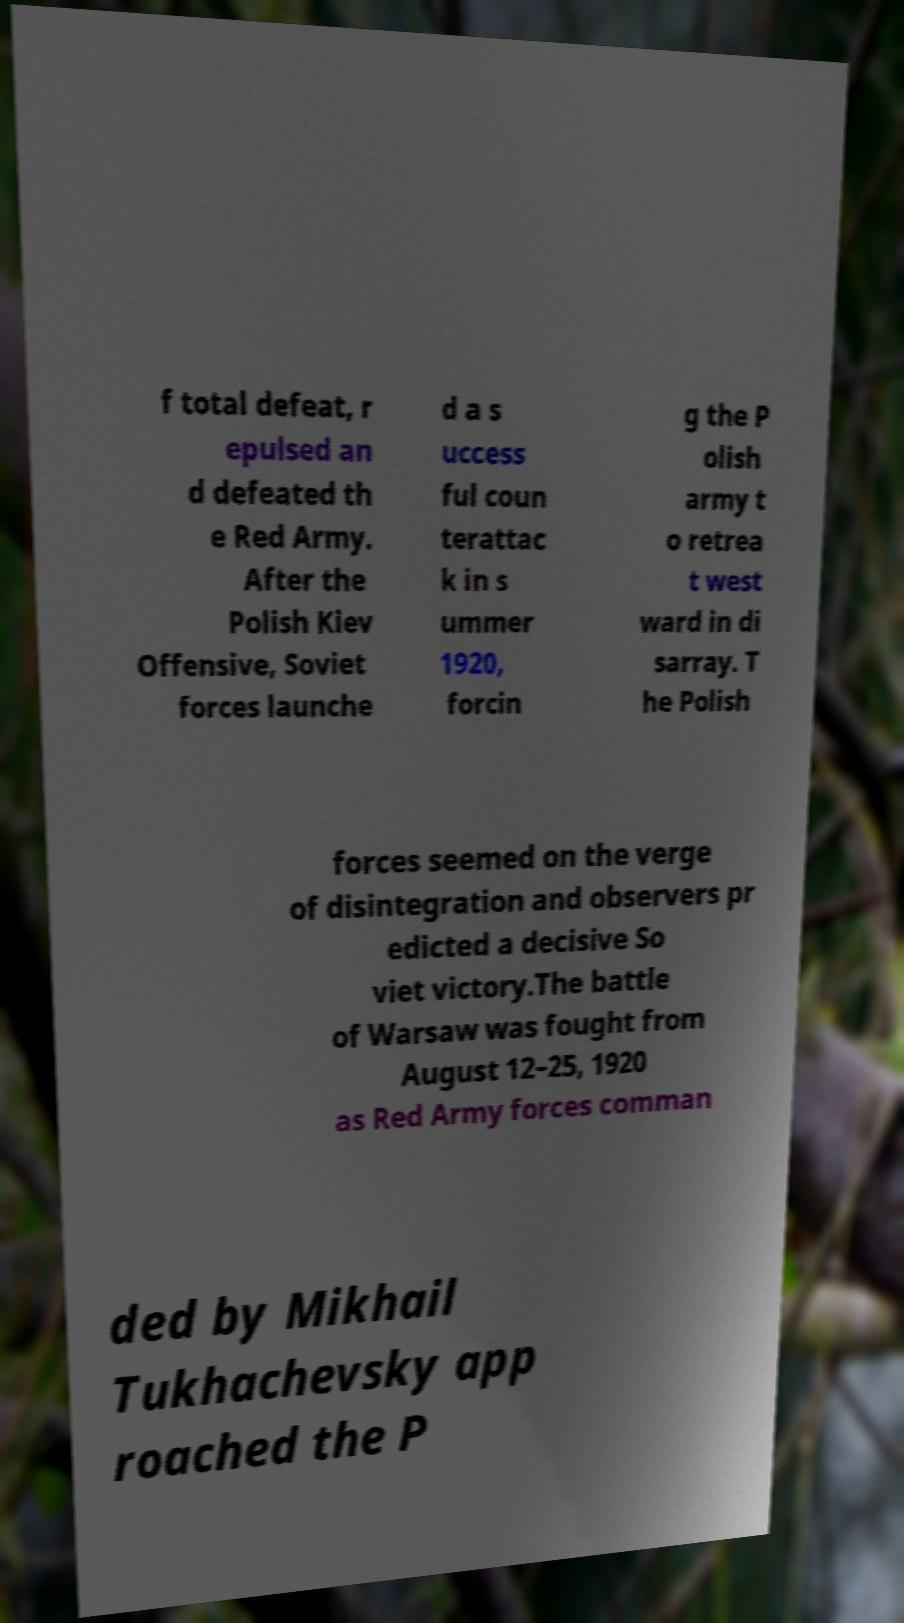Can you read and provide the text displayed in the image?This photo seems to have some interesting text. Can you extract and type it out for me? f total defeat, r epulsed an d defeated th e Red Army. After the Polish Kiev Offensive, Soviet forces launche d a s uccess ful coun terattac k in s ummer 1920, forcin g the P olish army t o retrea t west ward in di sarray. T he Polish forces seemed on the verge of disintegration and observers pr edicted a decisive So viet victory.The battle of Warsaw was fought from August 12–25, 1920 as Red Army forces comman ded by Mikhail Tukhachevsky app roached the P 